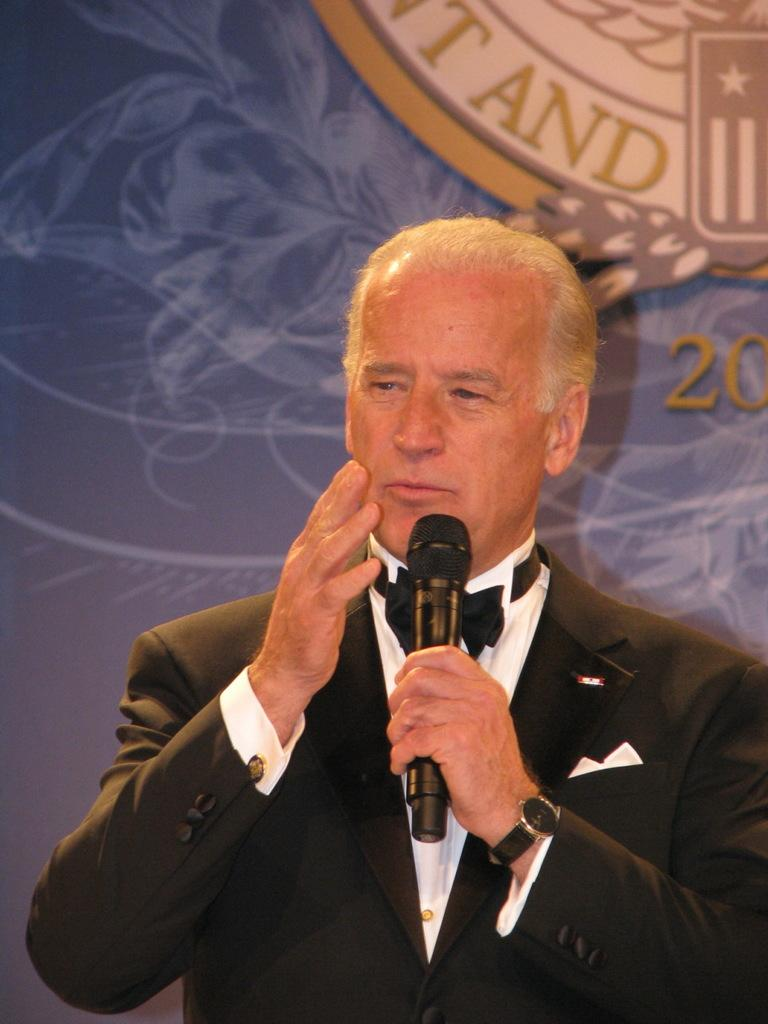What is the main subject of the image? The main subject of the image is a man. What is the man wearing on his upper body? The man is wearing a blazer. What accessory is the man wearing on his wrist? The man is wearing a watch. What is unique about the man's shirt? The man's shirt has a ribbon. What is the man holding in his hand? The man is holding a microphone in his hand. What is the man doing in the image? The man appears to be talking. What can be seen in the background of the image? There is a wall with a logo in the background of the image. How many wrens are perched on the man's shoulder in the image? There are no wrens present in the image. What day of the week is depicted in the image? The image does not depict a specific day of the week. 